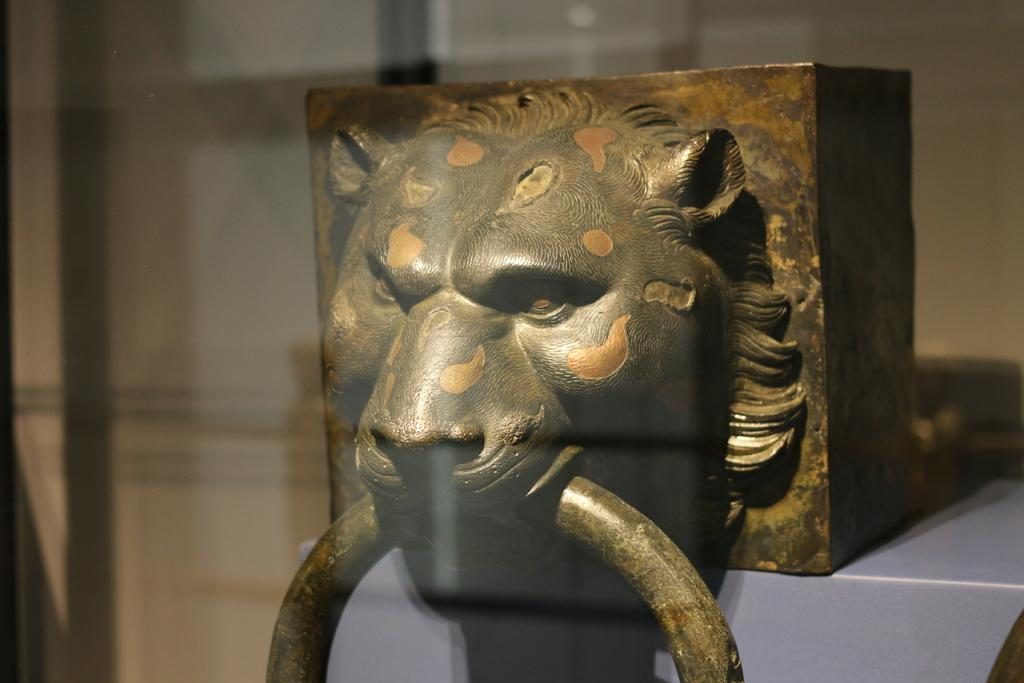What type of jelly is the cat using to spell out words in the image? There is no cat or jelly present in the image, and therefore no such activity can be observed. 